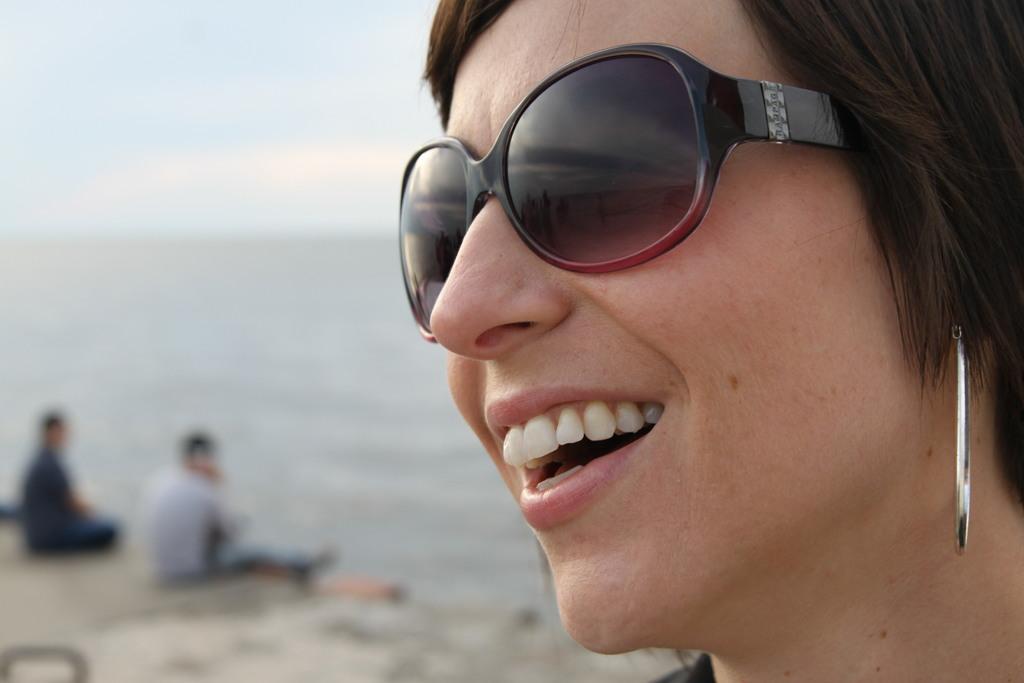Please provide a concise description of this image. In this image I can see a woman wearing black colored goggles and silver colored earring. In the background I can see the ground, two persons sitting on the ground and the sky. 